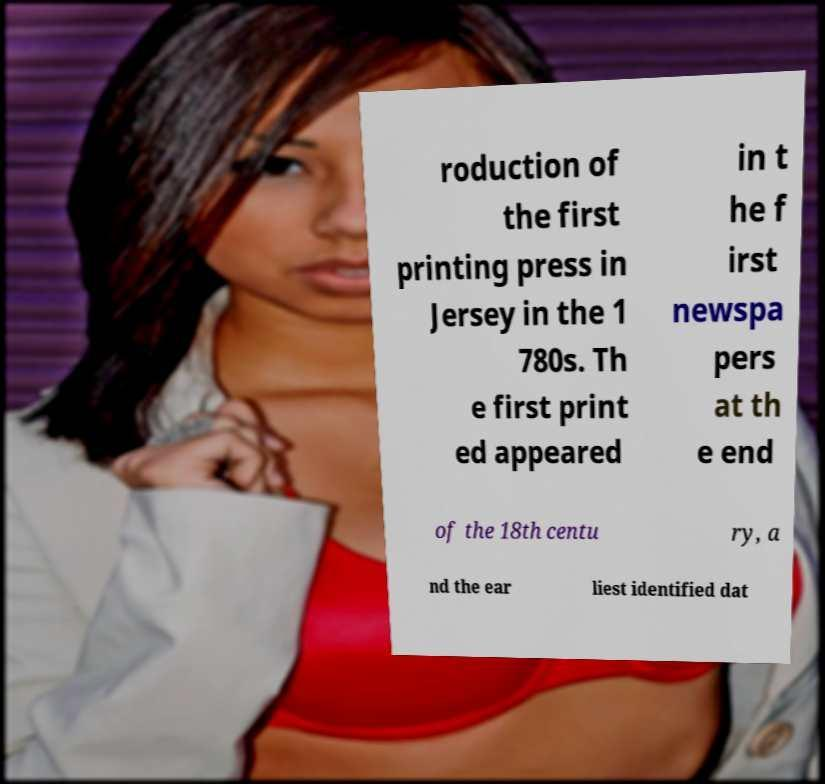Can you read and provide the text displayed in the image?This photo seems to have some interesting text. Can you extract and type it out for me? roduction of the first printing press in Jersey in the 1 780s. Th e first print ed appeared in t he f irst newspa pers at th e end of the 18th centu ry, a nd the ear liest identified dat 